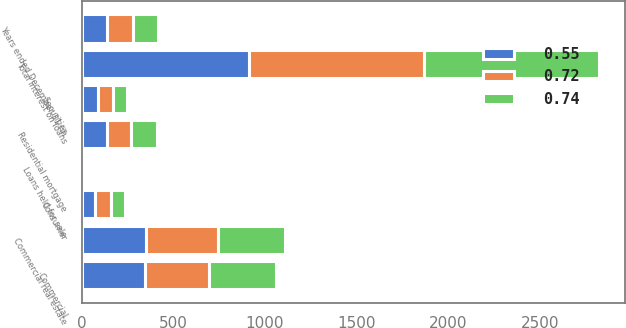Convert chart. <chart><loc_0><loc_0><loc_500><loc_500><stacked_bar_chart><ecel><fcel>Years ended December 31 (in<fcel>Commercial real estate<fcel>Commercial<fcel>Residential mortgage<fcel>Consumer<fcel>Total interest on loans<fcel>Securities<fcel>Loans held for sale<nl><fcel>0.55<fcel>139.9<fcel>351.2<fcel>347<fcel>139.9<fcel>74.8<fcel>912.9<fcel>89.7<fcel>1.5<nl><fcel>0.74<fcel>139.9<fcel>365.4<fcel>365.9<fcel>143.7<fcel>80<fcel>955<fcel>77.3<fcel>1.8<nl><fcel>0.72<fcel>139.9<fcel>392.4<fcel>348.6<fcel>129.1<fcel>84.2<fcel>954.3<fcel>83.4<fcel>2.1<nl></chart> 